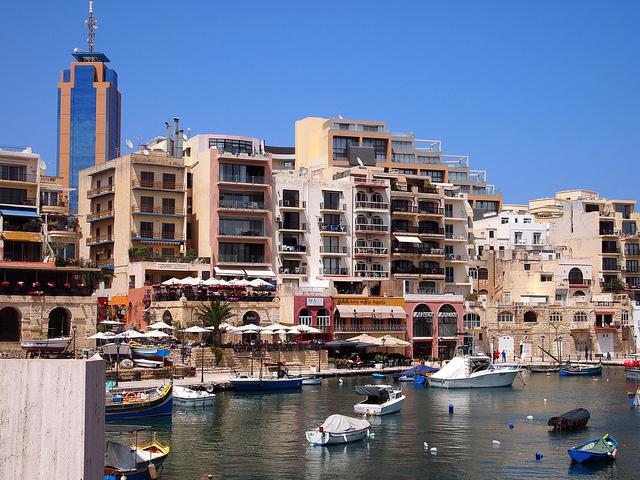What is function of the tallest building?
Answer briefly. Office. Is the water shallow?
Quick response, please. No. How many boats are in the water?
Be succinct. 12. Is this a resort?
Quick response, please. No. How tall is that far building?
Write a very short answer. Very. What color is the sky?
Short answer required. Blue. What is the weather like?
Quick response, please. Sunny. 